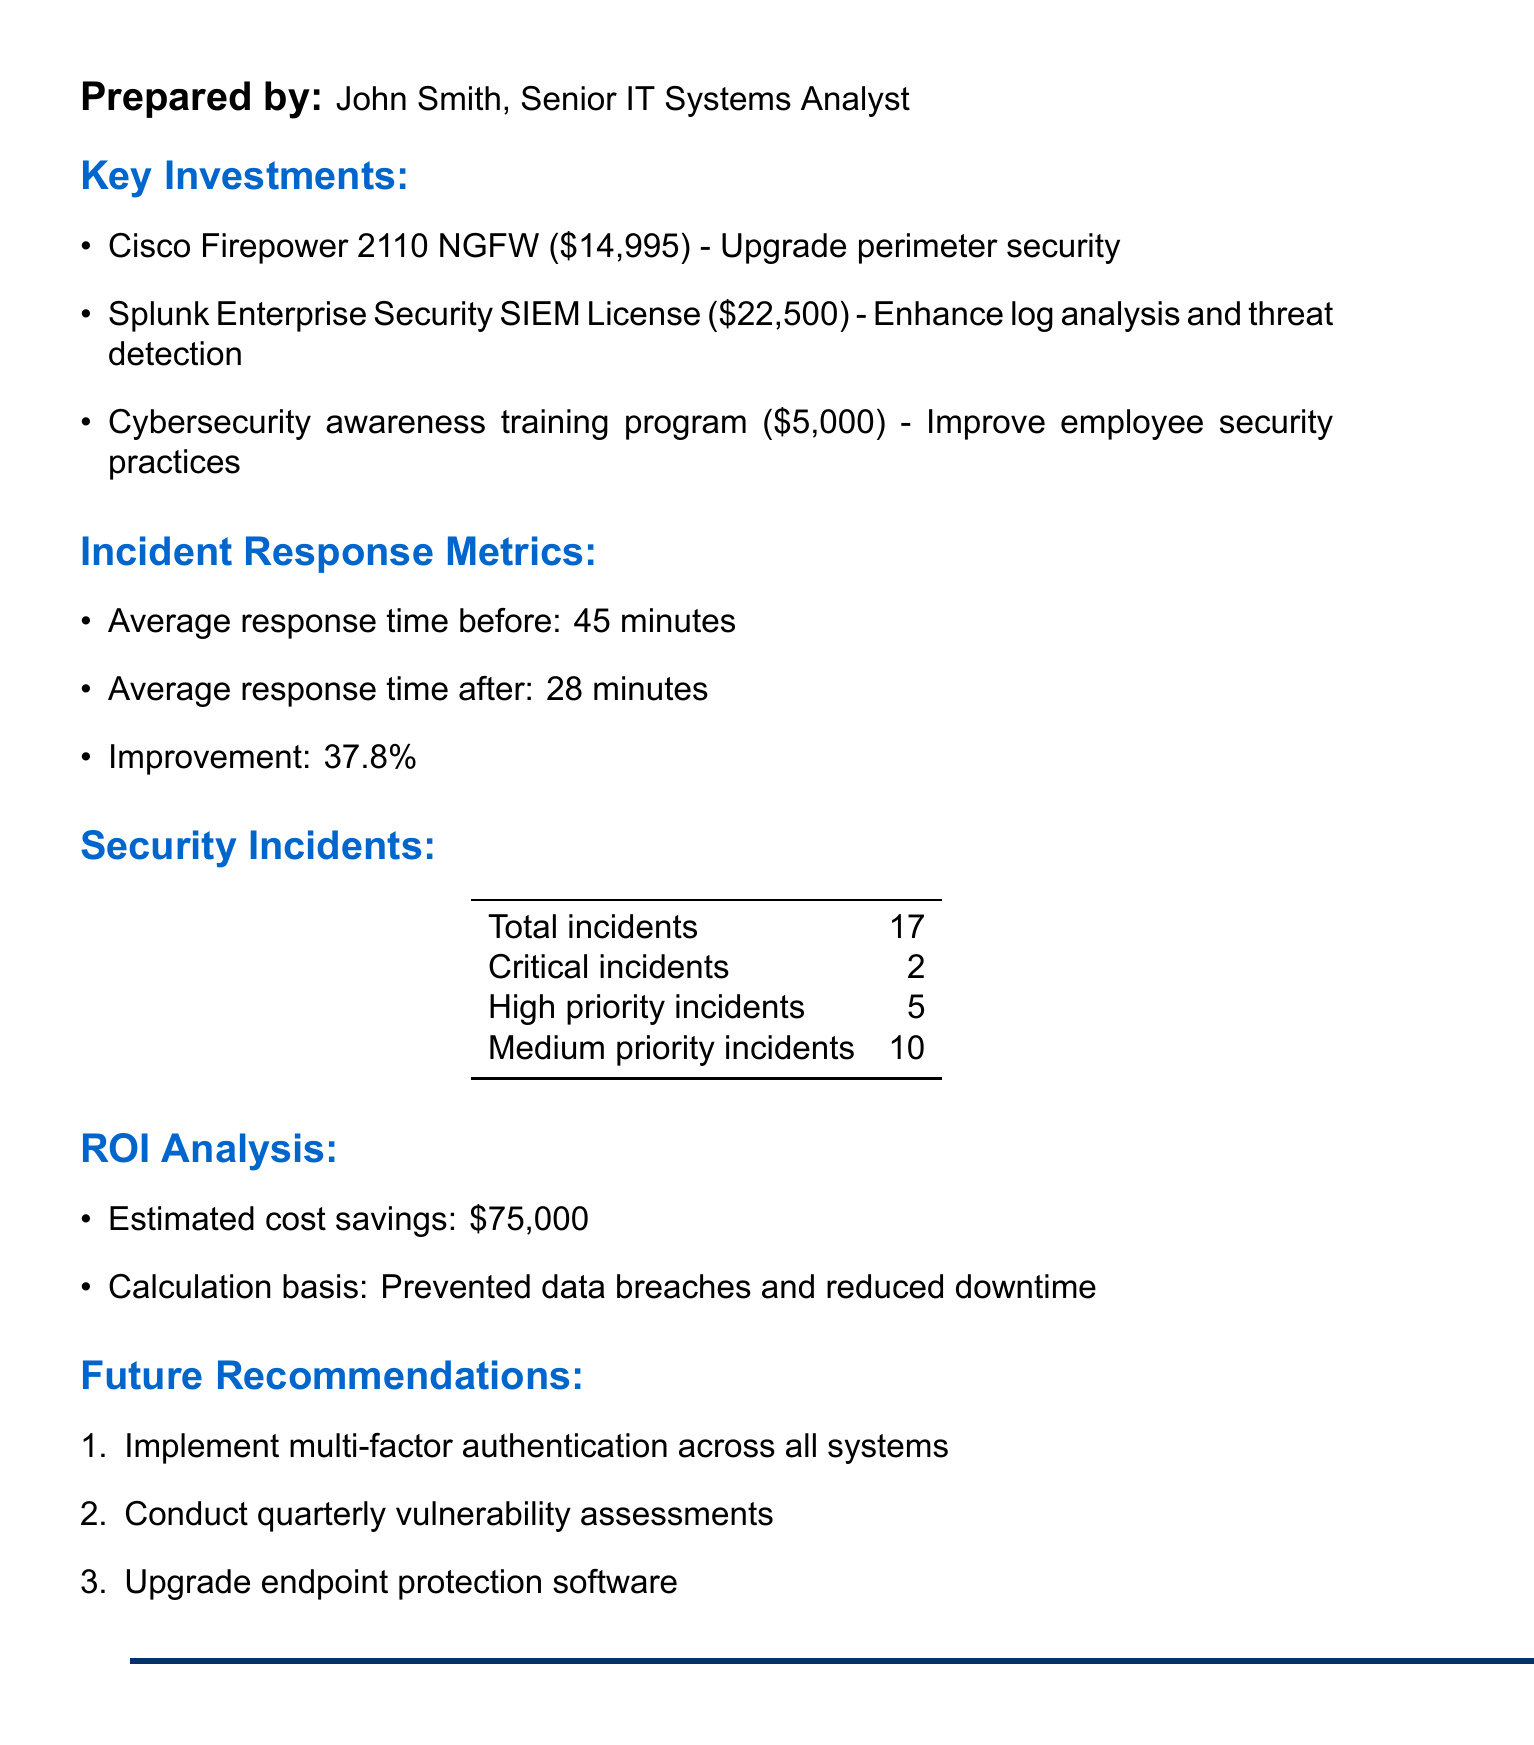What is the total cost of the key investments? The total cost is calculated by summing the costs of all key investments: $14,995 + $22,500 + $5,000 = $42,495.
Answer: $42,495 What is the average response time after investments? The average response time after investments indicates the efficiency post-investment, which is provided in the document as 28 minutes.
Answer: 28 minutes What percentage improvement in incident response time was achieved? The percentage improvement is calculated by comparing the response times before and after the investments, which is noted as 37.8%.
Answer: 37.8% How many total security incidents were reported? The total security incidents amount is the number noted in the document, which states there are 17 incidents.
Answer: 17 What tool was acquired for log analysis and threat detection? The document specifies that the Splunk Enterprise Security SIEM License was acquired for enhancing log analysis and threat detection.
Answer: Splunk Enterprise Security SIEM License What is the estimated cost savings from the investments? The estimated cost savings, relevant to the ROI analysis provided in the document, is noted as $75,000.
Answer: $75,000 Which investment focuses on employee security practices? The investment that aims to improve employee security practices is the cybersecurity awareness training program, as mentioned in the document.
Answer: Cybersecurity awareness training program What is one of the future recommendations? The document lists future recommendations; one such recommendation is to implement multi-factor authentication across all systems.
Answer: Implement multi-factor authentication across all systems 